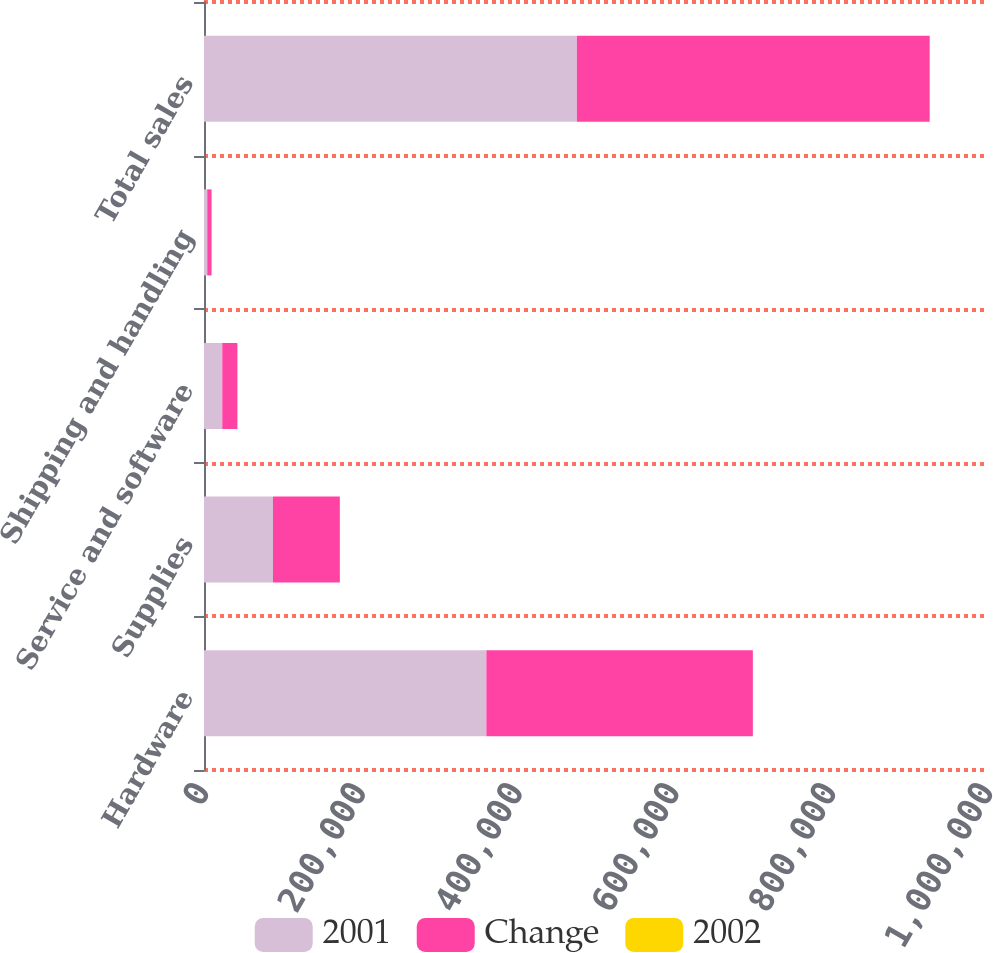Convert chart. <chart><loc_0><loc_0><loc_500><loc_500><stacked_bar_chart><ecel><fcel>Hardware<fcel>Supplies<fcel>Service and software<fcel>Shipping and handling<fcel>Total sales<nl><fcel>2001<fcel>360185<fcel>87981<fcel>23301<fcel>4144<fcel>475611<nl><fcel>Change<fcel>339895<fcel>85266<fcel>19336<fcel>5511<fcel>450008<nl><fcel>2002<fcel>6<fcel>3.2<fcel>20.5<fcel>24.8<fcel>5.7<nl></chart> 